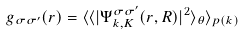<formula> <loc_0><loc_0><loc_500><loc_500>g _ { \sigma \sigma ^ { \prime } } ( r ) = \langle \langle | \Psi _ { { k } , { K } } ^ { \sigma \sigma ^ { \prime } } ( { r } , { R } ) | ^ { 2 } \rangle _ { \theta } \rangle _ { p ( k ) }</formula> 